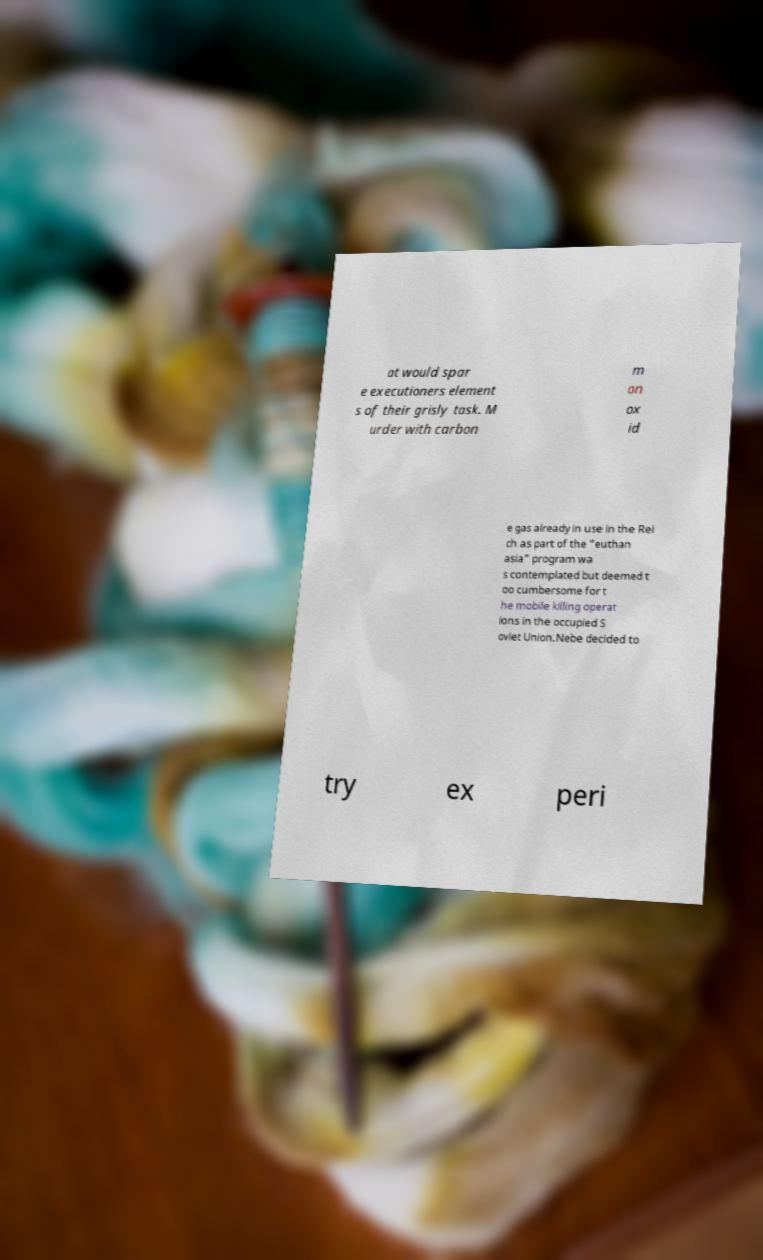I need the written content from this picture converted into text. Can you do that? at would spar e executioners element s of their grisly task. M urder with carbon m on ox id e gas already in use in the Rei ch as part of the "euthan asia" program wa s contemplated but deemed t oo cumbersome for t he mobile killing operat ions in the occupied S oviet Union.Nebe decided to try ex peri 